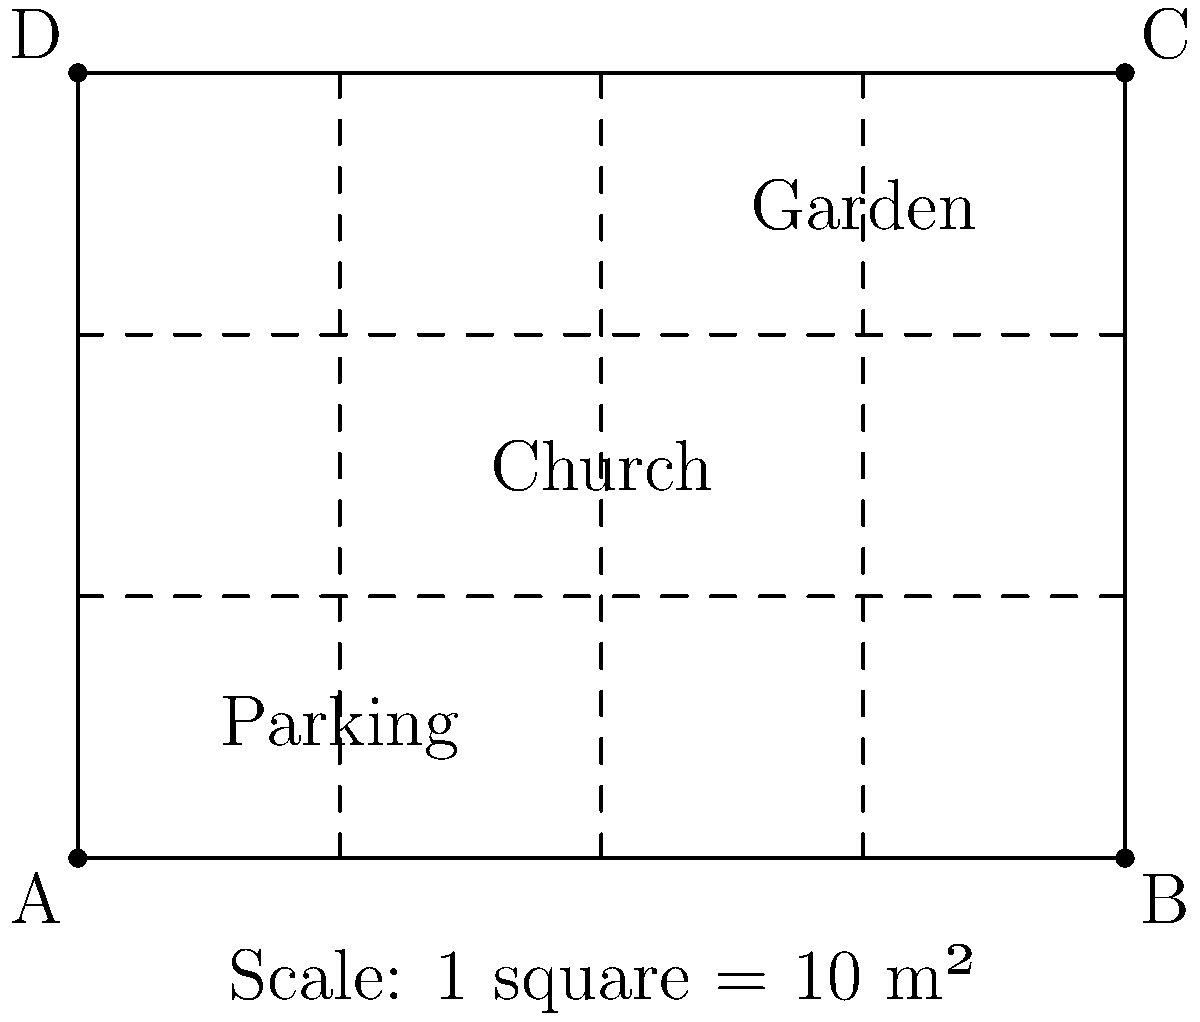Using the scaled map of the church property, estimate its total area in square meters. Each square on the map represents 10 m². Round your answer to the nearest 10 m². To estimate the area of the church property, we'll follow these steps:

1. Count the number of whole squares:
   - There are 24 whole squares (4 rows × 6 columns)

2. Count the number of partial squares:
   - There are no partial squares in this case

3. Calculate the total number of squares:
   24 whole squares + 0 partial squares = 24 total squares

4. Convert squares to area:
   - Each square represents 10 m²
   - Total area = 24 × 10 m² = 240 m²

5. Round to the nearest 10 m²:
   240 m² is already a multiple of 10, so no rounding is necessary

Therefore, the estimated area of the church property is 240 m².
Answer: 240 m² 